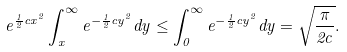<formula> <loc_0><loc_0><loc_500><loc_500>e ^ { \frac { 1 } { 2 } c x ^ { 2 } } \int _ { x } ^ { \infty } { e ^ { - \frac { 1 } { 2 } c y ^ { 2 } } d y } \leq \int _ { 0 } ^ { \infty } { e ^ { - \frac { 1 } { 2 } c y ^ { 2 } } d y } = \sqrt { \frac { \pi } { 2 c } } .</formula> 